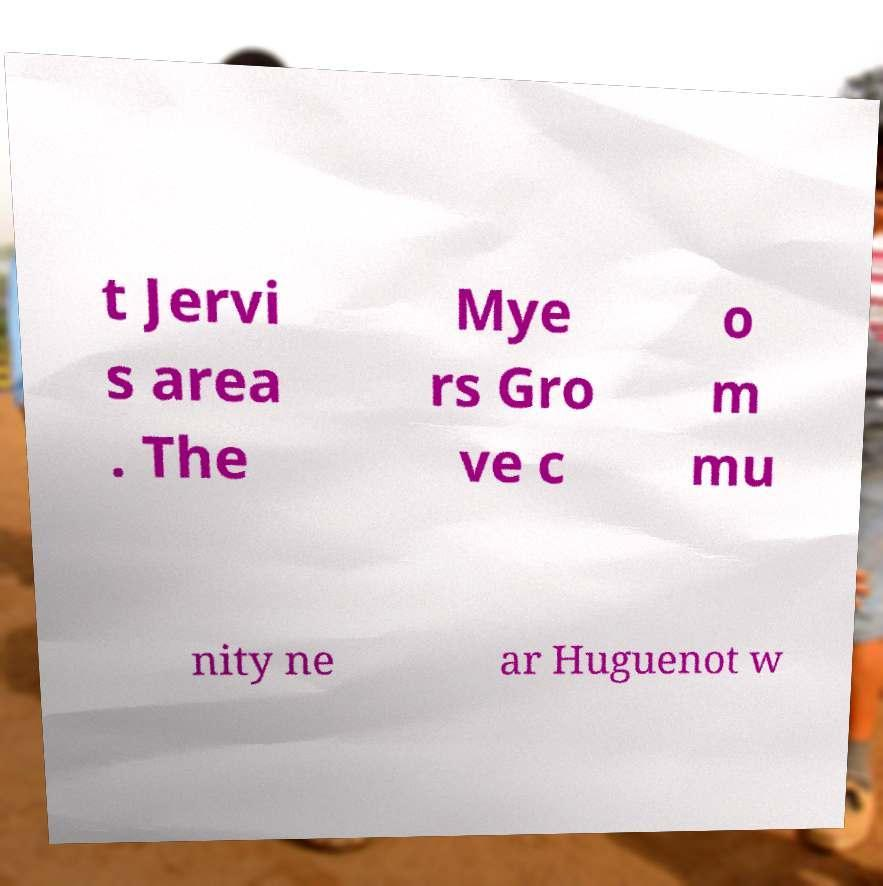Could you assist in decoding the text presented in this image and type it out clearly? t Jervi s area . The Mye rs Gro ve c o m mu nity ne ar Huguenot w 